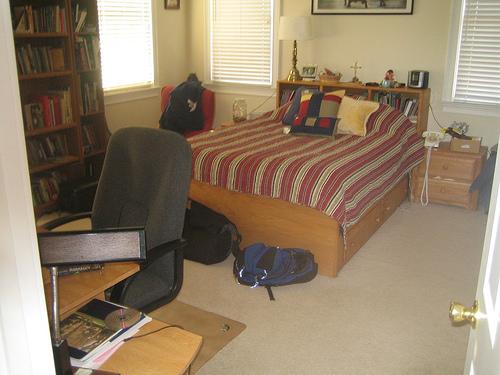What is the pattern on the bed linens?
Answer briefly. Stripes. Is this a little kids bedroom?
Give a very brief answer. No. Are both pillows the same?
Write a very short answer. No. 